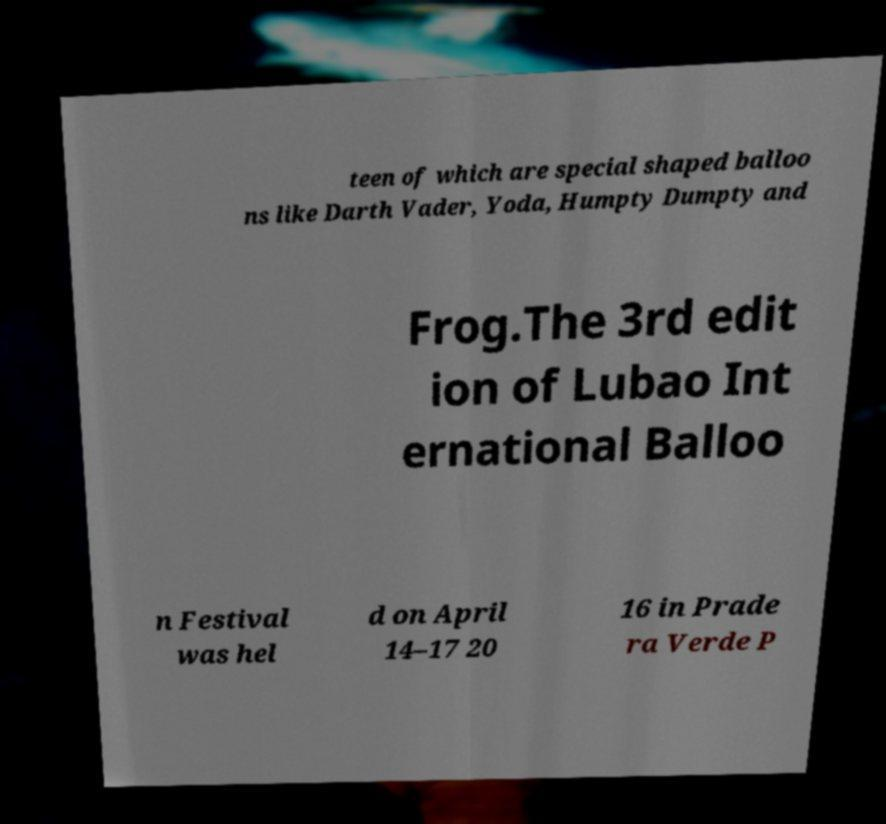Could you assist in decoding the text presented in this image and type it out clearly? teen of which are special shaped balloo ns like Darth Vader, Yoda, Humpty Dumpty and Frog.The 3rd edit ion of Lubao Int ernational Balloo n Festival was hel d on April 14–17 20 16 in Prade ra Verde P 